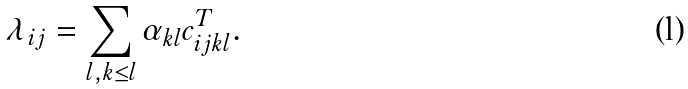<formula> <loc_0><loc_0><loc_500><loc_500>\lambda _ { i j } = \sum _ { l , k \leq l } \alpha _ { k l } c _ { i j k l } ^ { T } .</formula> 